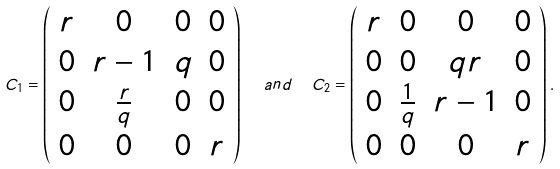Convert formula to latex. <formula><loc_0><loc_0><loc_500><loc_500>C _ { 1 } = \left ( \begin{array} { c c c c } r & 0 & 0 & 0 \\ 0 & r - 1 & q & 0 \\ 0 & \frac { r } { q } & 0 & 0 \\ 0 & 0 & 0 & r \end{array} \right ) \ \ a n d \ \ C _ { 2 } = \left ( \begin{array} { c c c c } r & 0 & 0 & 0 \\ 0 & 0 & q r & 0 \\ 0 & \frac { 1 } { q } & r - 1 & 0 \\ 0 & 0 & 0 & r \end{array} \right ) .</formula> 